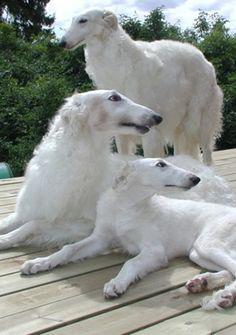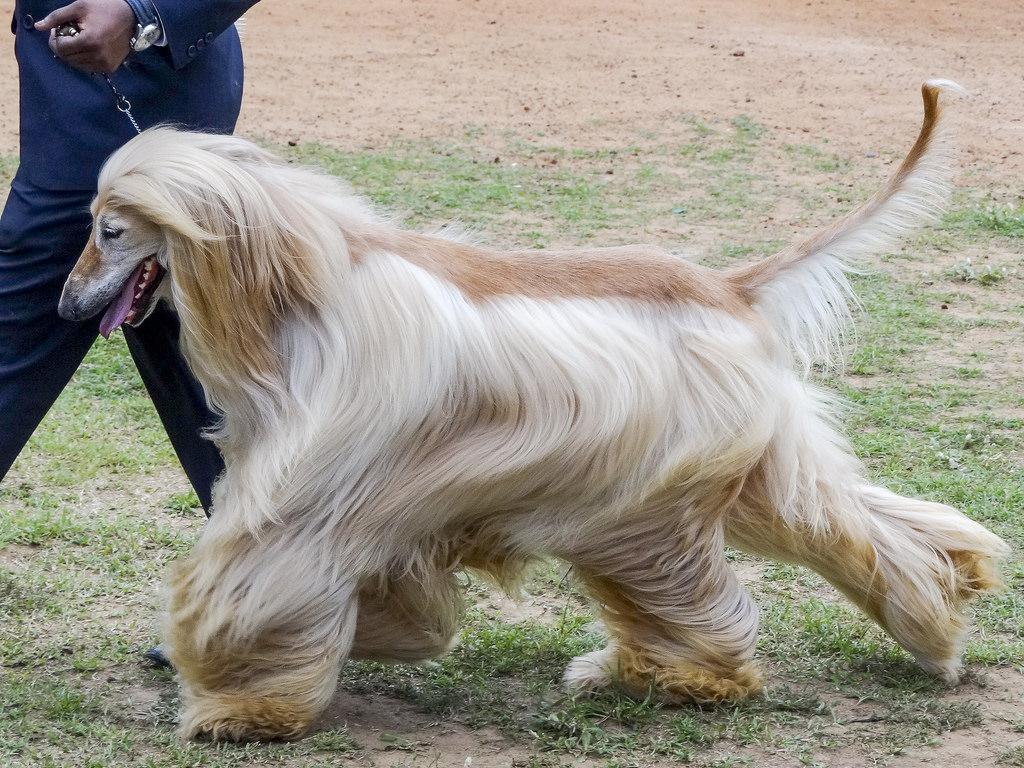The first image is the image on the left, the second image is the image on the right. Analyze the images presented: Is the assertion "The right image contains one hound standing in profile with its body turned leftward, and the left image contains three hounds with their heads not all pointed in the same direction." valid? Answer yes or no. Yes. The first image is the image on the left, the second image is the image on the right. Analyze the images presented: Is the assertion "The left image contains three dogs." valid? Answer yes or no. Yes. 